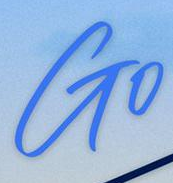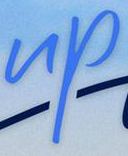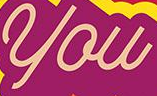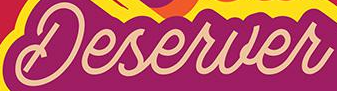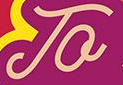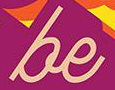Transcribe the words shown in these images in order, separated by a semicolon. Go; up; you; Deserver; To; be 